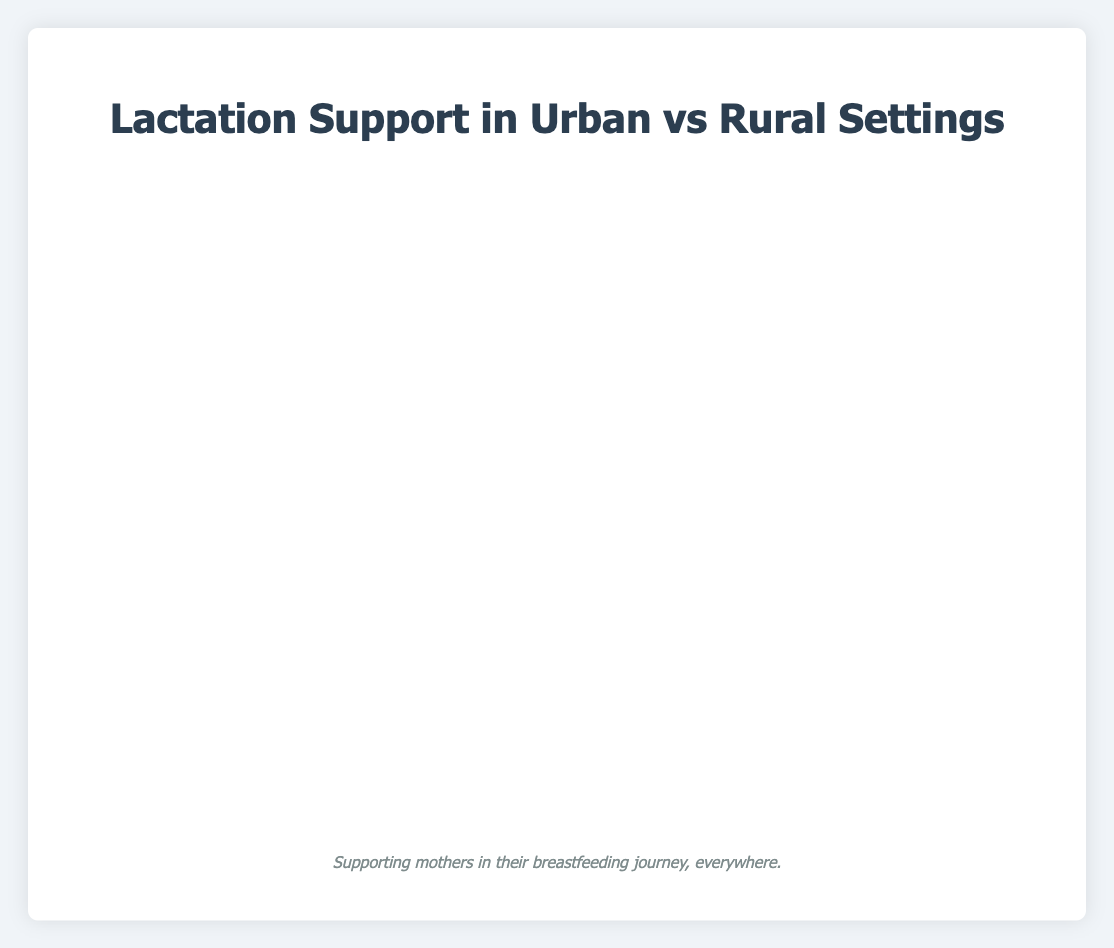What's the percentage difference in the use of Lactation Consultants between urban and rural settings? The percentage usage of Lactation Consultants in urban settings is 85, and in rural settings, it is 45. The difference is calculated as 85 - 45 = 40 percent.
Answer: 40% Which type of lactation support shows the most significant reliance on by rural mothers compared to urban mothers? By comparing each support category between urban and rural, "Family and Friends" has a higher percentage in rural (85) compared to urban (75). Hence, the most significant reliance by rural mothers is on "Family and Friends."
Answer: Family and Friends What is the combined percentage of new mothers in urban settings seeking Pediatrician Advice and Online Forums? The percentage for Pediatrician Advice is 90, and Online Forums is 95 in urban settings. The combined percentage is 90 + 95 = 185 percent.
Answer: 185% Compare the use of Hospital Lactation Services between urban and rural settings. The percentage of new mothers using Hospital Lactation Services in urban settings is 88, and in rural settings is 50. Urban settings show a higher percentage than rural settings by 88 - 50 = 38 percent.
Answer: Urban > Rural by 38% Which type of lactation support shows the least difference in usage percentages between urban and rural settings? By examining each bar length for the percentage differences: Midwife Support (Urban: 70, Rural: 68) shows the smallest difference of 2 percent.
Answer: Midwife Support How does the pattern of online support (Online Forums and Breastfeeding Hotlines) differ between rural and urban settings? Urban settings show higher percentages for both Online Forums (95) and Breastfeeding Hotlines (65) compared to rural settings (78 for Online Forums and 55 for Breastfeeding Hotlines). Rural settings still use more Online Forums than Breastfeeding Hotlines but with smaller margins.
Answer: Urban > Rural What is the average percentage of new mothers in urban settings seeking Lactation Consultants, Midwife Support, and Hospital Lactation Services? Urban percentages are 85 (Lactation Consultants), 70 (Midwife Support), and 88 (Hospital Lactation Services). The average is (85 + 70 + 88) / 3 = 81 percent.
Answer: 81% Which two types of lactation support have almost equal usage in rural settings? Visual comparison indicates that Midwife Support (68) and Family and Friends (85) are closest in values. Second check shows Lactation Consultants (45) and Breastfeeding Hotlines (55) being closer in usage, but Lactation Consultants and Breastfeeding Support Groups (52) are even closer. Therefore, Lactation Consultants (45) and Breastfeeding Support Groups (52) have the smallest difference.
Answer: Lactation Consultants and Breastfeeding Support Groups What is the median percentage usage of lactation support types in urban settings? For the urban setting values: [60, 65, 70, 72, 75, 85, 88, 90, 95], sort them to get: [60, 65, 70, 72, 75, 85, 88, 90, 95]. The median value is the middle number, which is 75.
Answer: 75 